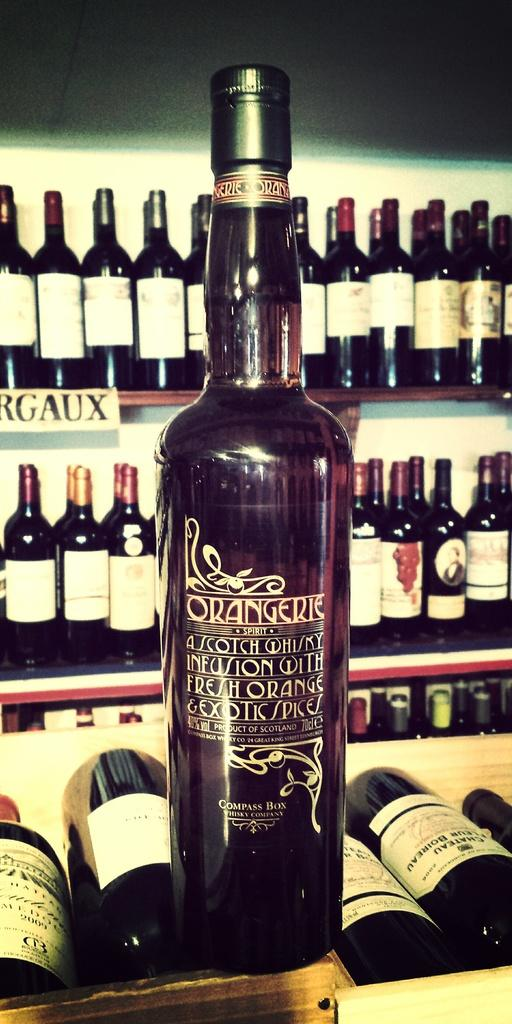<image>
Write a terse but informative summary of the picture. A bottle of Orangerie sits on a crate filled with bottles. 